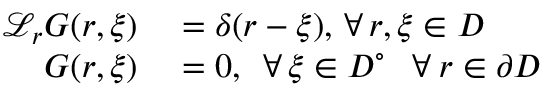Convert formula to latex. <formula><loc_0><loc_0><loc_500><loc_500>\begin{array} { r l } { \mathcal { L } _ { r } G ( r , \xi ) } & = \delta ( r - \xi ) , \, \forall \, r , \xi \in D } \\ { G ( r , \xi ) } & = 0 , \, \forall \, \xi \in D ^ { \circ } \, \forall \, r \in \partial D } \end{array}</formula> 